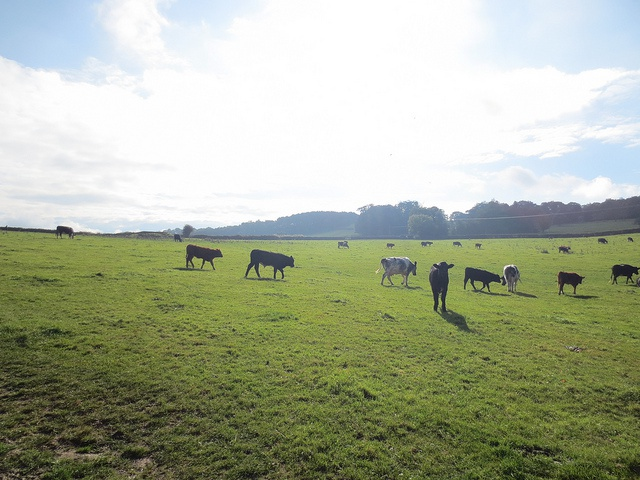Describe the objects in this image and their specific colors. I can see cow in lightblue, black, gray, and olive tones, cow in lightblue, black, and gray tones, cow in lightblue, olive, gray, and darkgray tones, cow in lightblue, gray, olive, and darkgray tones, and cow in lightblue, black, gray, and olive tones in this image. 